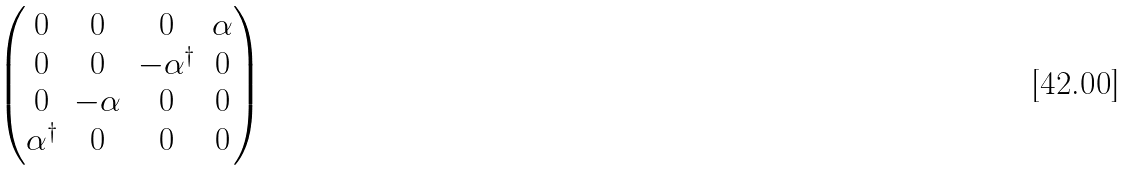<formula> <loc_0><loc_0><loc_500><loc_500>\begin{pmatrix} 0 & 0 & 0 & \alpha \\ 0 & 0 & - \alpha ^ { \dagger } & 0 \\ 0 & - \alpha & 0 & 0 \\ \alpha ^ { \dagger } & 0 & 0 & 0 \end{pmatrix}</formula> 